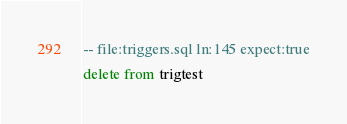<code> <loc_0><loc_0><loc_500><loc_500><_SQL_>-- file:triggers.sql ln:145 expect:true
delete from trigtest
</code> 